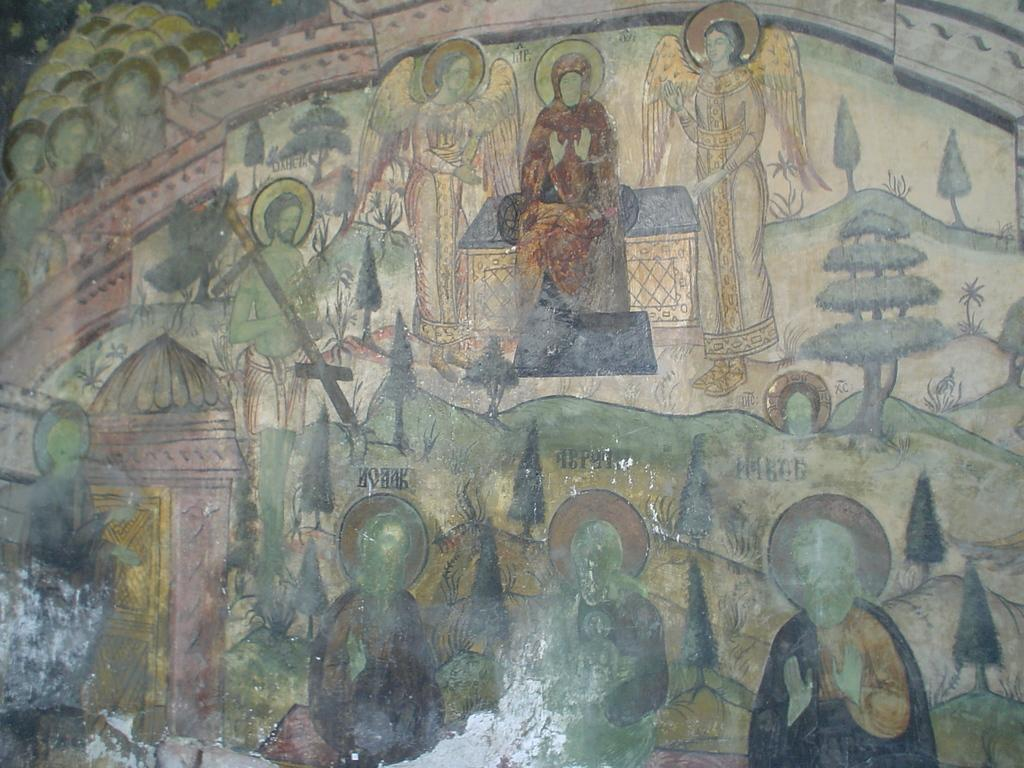What is the main subject of the image? The image contains a painting. What types of subjects are included in the painting? The painting includes people, trees, plants, houses, and other objects. Can you describe the setting of the painting? The painting includes a combination of natural elements like trees and plants, as well as man-made structures like houses. How many girls are climbing the rock in the painting? There is no rock or girls present in the painting; it features people, trees, plants, houses, and other objects. 